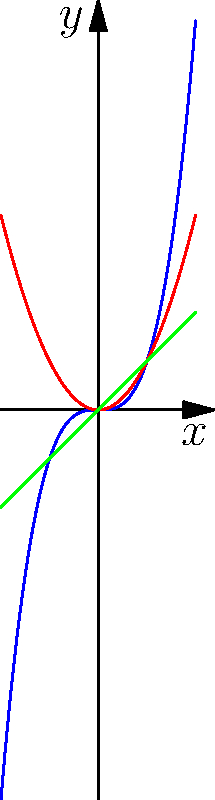As an experienced repairman who pays close attention to detail, analyze the behavior of the three polynomial functions shown in the graph. Which function will have the steepest slope as x approaches positive infinity, and why? To determine which function will have the steepest slope as x approaches positive infinity, we need to carefully examine each polynomial:

1. Green line: $f(x) = x$ (linear function, degree 1)
   - Slope is constant at 1
   
2. Red curve: $f(x) = x^2$ (quadratic function, degree 2)
   - Slope increases as x increases
   - Rate of change is linear: $\frac{d}{dx}(x^2) = 2x$
   
3. Blue curve: $f(x) = x^3$ (cubic function, degree 3)
   - Slope increases faster than the quadratic function
   - Rate of change is quadratic: $\frac{d}{dx}(x^3) = 3x^2$

As x approaches positive infinity:
- The linear function's slope remains constant at 1
- The quadratic function's slope increases linearly (2x)
- The cubic function's slope increases quadratically (3x^2)

Since $3x^2$ grows faster than $2x$ and 1 as x increases, the cubic function $f(x) = x^3$ will have the steepest slope as x approaches positive infinity.
Answer: $f(x) = x^3$ (cubic function) 